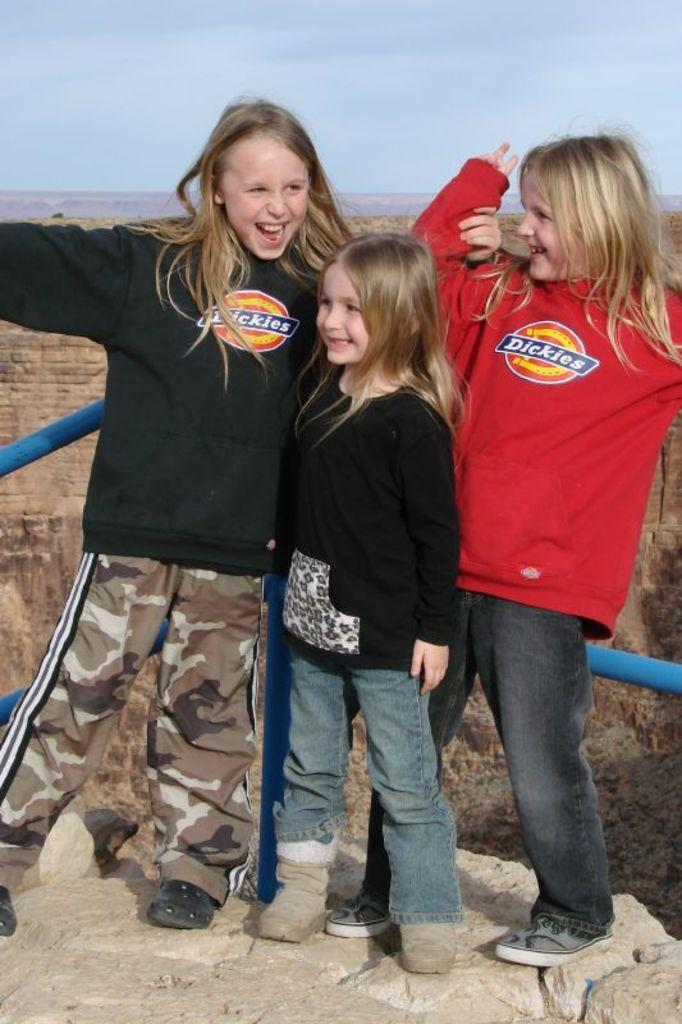How many people are in the image? There are three girls in the image. What are the girls doing in the image? The girls are standing on a rock. What expression do the girls have in the image? The girls have smiles on their faces. What can be seen in the sky in the image? There are clouds in the sky. What type of bun is the girl on the left holding in the image? There is no bun visible in the image; the girls are standing on a rock and have smiles on their faces. 